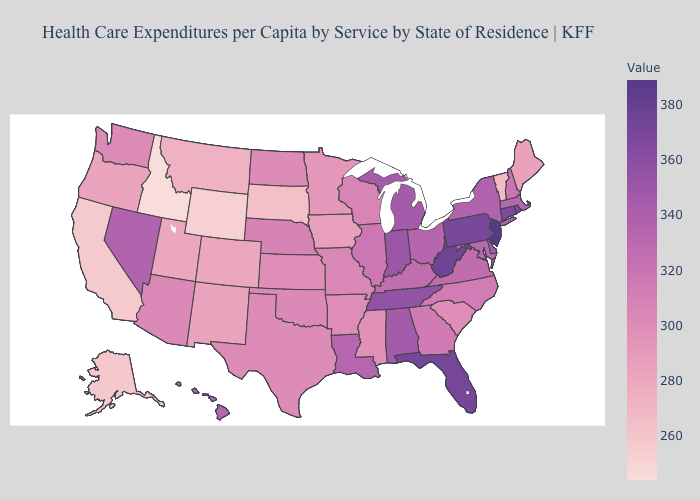Among the states that border Georgia , which have the highest value?
Write a very short answer. Florida. Which states have the lowest value in the Northeast?
Write a very short answer. Vermont. Does North Carolina have the lowest value in the USA?
Write a very short answer. No. Among the states that border Indiana , which have the highest value?
Write a very short answer. Michigan. Does New Jersey have the highest value in the USA?
Answer briefly. Yes. Is the legend a continuous bar?
Quick response, please. Yes. Does Illinois have the highest value in the MidWest?
Give a very brief answer. No. 